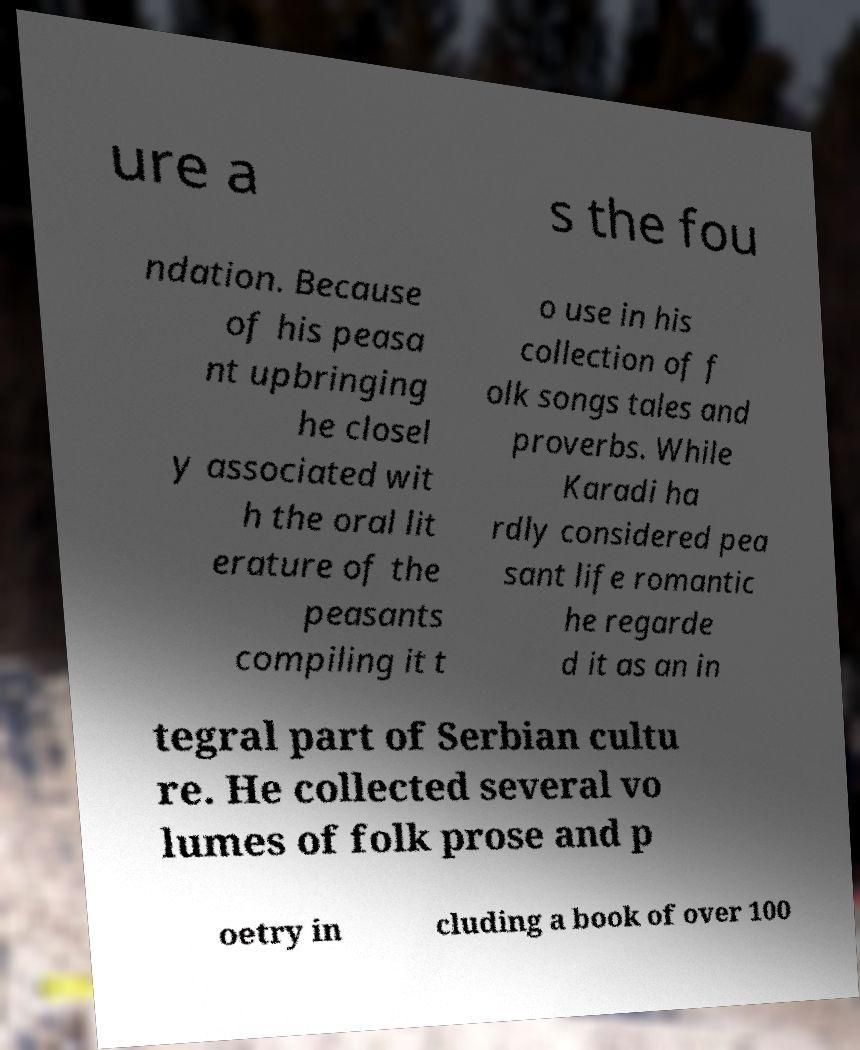For documentation purposes, I need the text within this image transcribed. Could you provide that? ure a s the fou ndation. Because of his peasa nt upbringing he closel y associated wit h the oral lit erature of the peasants compiling it t o use in his collection of f olk songs tales and proverbs. While Karadi ha rdly considered pea sant life romantic he regarde d it as an in tegral part of Serbian cultu re. He collected several vo lumes of folk prose and p oetry in cluding a book of over 100 